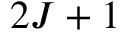<formula> <loc_0><loc_0><loc_500><loc_500>2 J + 1</formula> 